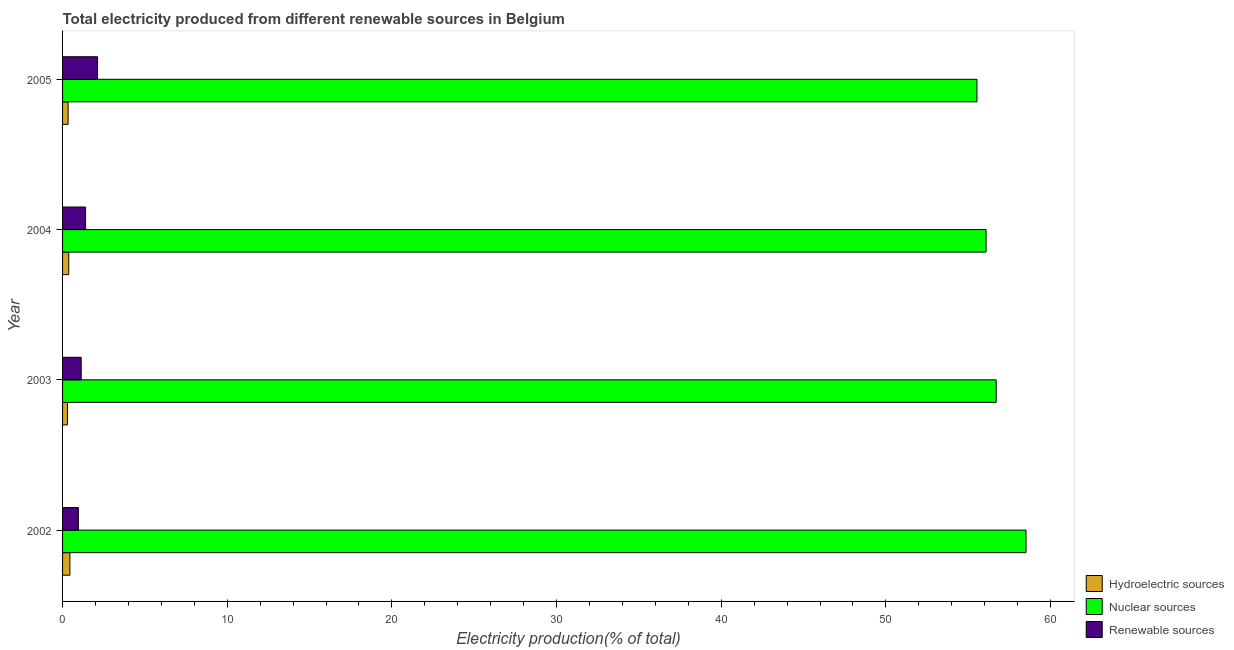How many bars are there on the 2nd tick from the bottom?
Your answer should be compact. 3. What is the label of the 2nd group of bars from the top?
Provide a succinct answer. 2004. In how many cases, is the number of bars for a given year not equal to the number of legend labels?
Your answer should be compact. 0. What is the percentage of electricity produced by nuclear sources in 2004?
Offer a very short reply. 56.09. Across all years, what is the maximum percentage of electricity produced by renewable sources?
Give a very brief answer. 2.12. Across all years, what is the minimum percentage of electricity produced by renewable sources?
Your answer should be compact. 0.96. In which year was the percentage of electricity produced by nuclear sources maximum?
Provide a short and direct response. 2002. In which year was the percentage of electricity produced by nuclear sources minimum?
Ensure brevity in your answer.  2005. What is the total percentage of electricity produced by nuclear sources in the graph?
Your answer should be very brief. 226.83. What is the difference between the percentage of electricity produced by hydroelectric sources in 2002 and that in 2005?
Make the answer very short. 0.11. What is the difference between the percentage of electricity produced by nuclear sources in 2003 and the percentage of electricity produced by hydroelectric sources in 2004?
Keep it short and to the point. 56.32. What is the average percentage of electricity produced by nuclear sources per year?
Ensure brevity in your answer.  56.71. In the year 2002, what is the difference between the percentage of electricity produced by renewable sources and percentage of electricity produced by hydroelectric sources?
Offer a terse response. 0.52. In how many years, is the percentage of electricity produced by renewable sources greater than 36 %?
Ensure brevity in your answer.  0. What is the ratio of the percentage of electricity produced by nuclear sources in 2003 to that in 2004?
Offer a very short reply. 1.01. Is the percentage of electricity produced by renewable sources in 2003 less than that in 2005?
Give a very brief answer. Yes. Is the difference between the percentage of electricity produced by nuclear sources in 2003 and 2004 greater than the difference between the percentage of electricity produced by renewable sources in 2003 and 2004?
Offer a very short reply. Yes. What is the difference between the highest and the second highest percentage of electricity produced by nuclear sources?
Offer a very short reply. 1.81. What is the difference between the highest and the lowest percentage of electricity produced by renewable sources?
Make the answer very short. 1.16. What does the 1st bar from the top in 2004 represents?
Provide a short and direct response. Renewable sources. What does the 3rd bar from the bottom in 2003 represents?
Your response must be concise. Renewable sources. How many bars are there?
Your answer should be very brief. 12. How many years are there in the graph?
Ensure brevity in your answer.  4. Does the graph contain any zero values?
Give a very brief answer. No. Does the graph contain grids?
Keep it short and to the point. No. Where does the legend appear in the graph?
Give a very brief answer. Bottom right. How many legend labels are there?
Make the answer very short. 3. What is the title of the graph?
Your answer should be compact. Total electricity produced from different renewable sources in Belgium. Does "Grants" appear as one of the legend labels in the graph?
Provide a succinct answer. No. What is the label or title of the X-axis?
Keep it short and to the point. Electricity production(% of total). What is the Electricity production(% of total) in Hydroelectric sources in 2002?
Your answer should be very brief. 0.44. What is the Electricity production(% of total) in Nuclear sources in 2002?
Make the answer very short. 58.51. What is the Electricity production(% of total) in Renewable sources in 2002?
Make the answer very short. 0.96. What is the Electricity production(% of total) in Hydroelectric sources in 2003?
Make the answer very short. 0.3. What is the Electricity production(% of total) in Nuclear sources in 2003?
Your answer should be compact. 56.7. What is the Electricity production(% of total) of Renewable sources in 2003?
Provide a short and direct response. 1.13. What is the Electricity production(% of total) in Hydroelectric sources in 2004?
Give a very brief answer. 0.38. What is the Electricity production(% of total) of Nuclear sources in 2004?
Offer a terse response. 56.09. What is the Electricity production(% of total) of Renewable sources in 2004?
Keep it short and to the point. 1.4. What is the Electricity production(% of total) of Hydroelectric sources in 2005?
Make the answer very short. 0.34. What is the Electricity production(% of total) of Nuclear sources in 2005?
Ensure brevity in your answer.  55.53. What is the Electricity production(% of total) of Renewable sources in 2005?
Ensure brevity in your answer.  2.12. Across all years, what is the maximum Electricity production(% of total) in Hydroelectric sources?
Make the answer very short. 0.44. Across all years, what is the maximum Electricity production(% of total) of Nuclear sources?
Ensure brevity in your answer.  58.51. Across all years, what is the maximum Electricity production(% of total) in Renewable sources?
Offer a terse response. 2.12. Across all years, what is the minimum Electricity production(% of total) of Hydroelectric sources?
Keep it short and to the point. 0.3. Across all years, what is the minimum Electricity production(% of total) of Nuclear sources?
Provide a succinct answer. 55.53. Across all years, what is the minimum Electricity production(% of total) in Renewable sources?
Make the answer very short. 0.96. What is the total Electricity production(% of total) in Hydroelectric sources in the graph?
Your response must be concise. 1.45. What is the total Electricity production(% of total) of Nuclear sources in the graph?
Your answer should be very brief. 226.83. What is the total Electricity production(% of total) of Renewable sources in the graph?
Offer a terse response. 5.61. What is the difference between the Electricity production(% of total) of Hydroelectric sources in 2002 and that in 2003?
Provide a short and direct response. 0.15. What is the difference between the Electricity production(% of total) in Nuclear sources in 2002 and that in 2003?
Make the answer very short. 1.81. What is the difference between the Electricity production(% of total) of Renewable sources in 2002 and that in 2003?
Offer a terse response. -0.17. What is the difference between the Electricity production(% of total) of Hydroelectric sources in 2002 and that in 2004?
Make the answer very short. 0.07. What is the difference between the Electricity production(% of total) of Nuclear sources in 2002 and that in 2004?
Offer a very short reply. 2.43. What is the difference between the Electricity production(% of total) of Renewable sources in 2002 and that in 2004?
Provide a succinct answer. -0.44. What is the difference between the Electricity production(% of total) in Hydroelectric sources in 2002 and that in 2005?
Your answer should be very brief. 0.11. What is the difference between the Electricity production(% of total) in Nuclear sources in 2002 and that in 2005?
Provide a short and direct response. 2.98. What is the difference between the Electricity production(% of total) of Renewable sources in 2002 and that in 2005?
Your answer should be compact. -1.16. What is the difference between the Electricity production(% of total) of Hydroelectric sources in 2003 and that in 2004?
Make the answer very short. -0.08. What is the difference between the Electricity production(% of total) of Nuclear sources in 2003 and that in 2004?
Provide a succinct answer. 0.61. What is the difference between the Electricity production(% of total) of Renewable sources in 2003 and that in 2004?
Your response must be concise. -0.27. What is the difference between the Electricity production(% of total) in Hydroelectric sources in 2003 and that in 2005?
Give a very brief answer. -0.04. What is the difference between the Electricity production(% of total) in Nuclear sources in 2003 and that in 2005?
Make the answer very short. 1.17. What is the difference between the Electricity production(% of total) of Renewable sources in 2003 and that in 2005?
Your answer should be compact. -0.99. What is the difference between the Electricity production(% of total) of Hydroelectric sources in 2004 and that in 2005?
Offer a terse response. 0.04. What is the difference between the Electricity production(% of total) of Nuclear sources in 2004 and that in 2005?
Your answer should be very brief. 0.56. What is the difference between the Electricity production(% of total) in Renewable sources in 2004 and that in 2005?
Provide a short and direct response. -0.72. What is the difference between the Electricity production(% of total) in Hydroelectric sources in 2002 and the Electricity production(% of total) in Nuclear sources in 2003?
Offer a terse response. -56.26. What is the difference between the Electricity production(% of total) in Hydroelectric sources in 2002 and the Electricity production(% of total) in Renewable sources in 2003?
Keep it short and to the point. -0.69. What is the difference between the Electricity production(% of total) of Nuclear sources in 2002 and the Electricity production(% of total) of Renewable sources in 2003?
Provide a succinct answer. 57.38. What is the difference between the Electricity production(% of total) in Hydroelectric sources in 2002 and the Electricity production(% of total) in Nuclear sources in 2004?
Your answer should be compact. -55.64. What is the difference between the Electricity production(% of total) in Hydroelectric sources in 2002 and the Electricity production(% of total) in Renewable sources in 2004?
Keep it short and to the point. -0.95. What is the difference between the Electricity production(% of total) of Nuclear sources in 2002 and the Electricity production(% of total) of Renewable sources in 2004?
Provide a succinct answer. 57.11. What is the difference between the Electricity production(% of total) of Hydroelectric sources in 2002 and the Electricity production(% of total) of Nuclear sources in 2005?
Make the answer very short. -55.09. What is the difference between the Electricity production(% of total) of Hydroelectric sources in 2002 and the Electricity production(% of total) of Renewable sources in 2005?
Make the answer very short. -1.68. What is the difference between the Electricity production(% of total) in Nuclear sources in 2002 and the Electricity production(% of total) in Renewable sources in 2005?
Your answer should be compact. 56.39. What is the difference between the Electricity production(% of total) of Hydroelectric sources in 2003 and the Electricity production(% of total) of Nuclear sources in 2004?
Offer a very short reply. -55.79. What is the difference between the Electricity production(% of total) of Hydroelectric sources in 2003 and the Electricity production(% of total) of Renewable sources in 2004?
Your answer should be compact. -1.1. What is the difference between the Electricity production(% of total) of Nuclear sources in 2003 and the Electricity production(% of total) of Renewable sources in 2004?
Provide a short and direct response. 55.3. What is the difference between the Electricity production(% of total) in Hydroelectric sources in 2003 and the Electricity production(% of total) in Nuclear sources in 2005?
Your answer should be compact. -55.24. What is the difference between the Electricity production(% of total) of Hydroelectric sources in 2003 and the Electricity production(% of total) of Renewable sources in 2005?
Keep it short and to the point. -1.83. What is the difference between the Electricity production(% of total) in Nuclear sources in 2003 and the Electricity production(% of total) in Renewable sources in 2005?
Give a very brief answer. 54.58. What is the difference between the Electricity production(% of total) of Hydroelectric sources in 2004 and the Electricity production(% of total) of Nuclear sources in 2005?
Ensure brevity in your answer.  -55.16. What is the difference between the Electricity production(% of total) of Hydroelectric sources in 2004 and the Electricity production(% of total) of Renewable sources in 2005?
Your answer should be compact. -1.75. What is the difference between the Electricity production(% of total) in Nuclear sources in 2004 and the Electricity production(% of total) in Renewable sources in 2005?
Your answer should be compact. 53.97. What is the average Electricity production(% of total) of Hydroelectric sources per year?
Offer a terse response. 0.36. What is the average Electricity production(% of total) of Nuclear sources per year?
Keep it short and to the point. 56.71. What is the average Electricity production(% of total) in Renewable sources per year?
Your answer should be very brief. 1.4. In the year 2002, what is the difference between the Electricity production(% of total) in Hydroelectric sources and Electricity production(% of total) in Nuclear sources?
Provide a short and direct response. -58.07. In the year 2002, what is the difference between the Electricity production(% of total) of Hydroelectric sources and Electricity production(% of total) of Renewable sources?
Make the answer very short. -0.52. In the year 2002, what is the difference between the Electricity production(% of total) of Nuclear sources and Electricity production(% of total) of Renewable sources?
Keep it short and to the point. 57.55. In the year 2003, what is the difference between the Electricity production(% of total) in Hydroelectric sources and Electricity production(% of total) in Nuclear sources?
Keep it short and to the point. -56.4. In the year 2003, what is the difference between the Electricity production(% of total) of Hydroelectric sources and Electricity production(% of total) of Renewable sources?
Ensure brevity in your answer.  -0.84. In the year 2003, what is the difference between the Electricity production(% of total) of Nuclear sources and Electricity production(% of total) of Renewable sources?
Provide a short and direct response. 55.57. In the year 2004, what is the difference between the Electricity production(% of total) in Hydroelectric sources and Electricity production(% of total) in Nuclear sources?
Your response must be concise. -55.71. In the year 2004, what is the difference between the Electricity production(% of total) of Hydroelectric sources and Electricity production(% of total) of Renewable sources?
Keep it short and to the point. -1.02. In the year 2004, what is the difference between the Electricity production(% of total) in Nuclear sources and Electricity production(% of total) in Renewable sources?
Provide a succinct answer. 54.69. In the year 2005, what is the difference between the Electricity production(% of total) of Hydroelectric sources and Electricity production(% of total) of Nuclear sources?
Keep it short and to the point. -55.19. In the year 2005, what is the difference between the Electricity production(% of total) in Hydroelectric sources and Electricity production(% of total) in Renewable sources?
Provide a succinct answer. -1.79. In the year 2005, what is the difference between the Electricity production(% of total) in Nuclear sources and Electricity production(% of total) in Renewable sources?
Provide a succinct answer. 53.41. What is the ratio of the Electricity production(% of total) in Hydroelectric sources in 2002 to that in 2003?
Make the answer very short. 1.5. What is the ratio of the Electricity production(% of total) of Nuclear sources in 2002 to that in 2003?
Your answer should be very brief. 1.03. What is the ratio of the Electricity production(% of total) of Hydroelectric sources in 2002 to that in 2004?
Make the answer very short. 1.18. What is the ratio of the Electricity production(% of total) of Nuclear sources in 2002 to that in 2004?
Make the answer very short. 1.04. What is the ratio of the Electricity production(% of total) in Renewable sources in 2002 to that in 2004?
Your answer should be very brief. 0.69. What is the ratio of the Electricity production(% of total) of Hydroelectric sources in 2002 to that in 2005?
Provide a short and direct response. 1.32. What is the ratio of the Electricity production(% of total) in Nuclear sources in 2002 to that in 2005?
Offer a very short reply. 1.05. What is the ratio of the Electricity production(% of total) of Renewable sources in 2002 to that in 2005?
Offer a very short reply. 0.45. What is the ratio of the Electricity production(% of total) of Hydroelectric sources in 2003 to that in 2004?
Offer a very short reply. 0.79. What is the ratio of the Electricity production(% of total) in Nuclear sources in 2003 to that in 2004?
Ensure brevity in your answer.  1.01. What is the ratio of the Electricity production(% of total) of Renewable sources in 2003 to that in 2004?
Provide a succinct answer. 0.81. What is the ratio of the Electricity production(% of total) of Hydroelectric sources in 2003 to that in 2005?
Make the answer very short. 0.88. What is the ratio of the Electricity production(% of total) of Nuclear sources in 2003 to that in 2005?
Offer a terse response. 1.02. What is the ratio of the Electricity production(% of total) of Renewable sources in 2003 to that in 2005?
Provide a succinct answer. 0.53. What is the ratio of the Electricity production(% of total) in Hydroelectric sources in 2004 to that in 2005?
Provide a short and direct response. 1.12. What is the ratio of the Electricity production(% of total) in Renewable sources in 2004 to that in 2005?
Your answer should be compact. 0.66. What is the difference between the highest and the second highest Electricity production(% of total) in Hydroelectric sources?
Offer a very short reply. 0.07. What is the difference between the highest and the second highest Electricity production(% of total) of Nuclear sources?
Your answer should be very brief. 1.81. What is the difference between the highest and the second highest Electricity production(% of total) of Renewable sources?
Ensure brevity in your answer.  0.72. What is the difference between the highest and the lowest Electricity production(% of total) in Hydroelectric sources?
Ensure brevity in your answer.  0.15. What is the difference between the highest and the lowest Electricity production(% of total) of Nuclear sources?
Provide a short and direct response. 2.98. What is the difference between the highest and the lowest Electricity production(% of total) of Renewable sources?
Keep it short and to the point. 1.16. 